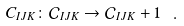Convert formula to latex. <formula><loc_0><loc_0><loc_500><loc_500>C _ { I J K } \colon \mathcal { C } _ { I J K } \rightarrow \mathcal { C } _ { I J K } + 1 \ .</formula> 